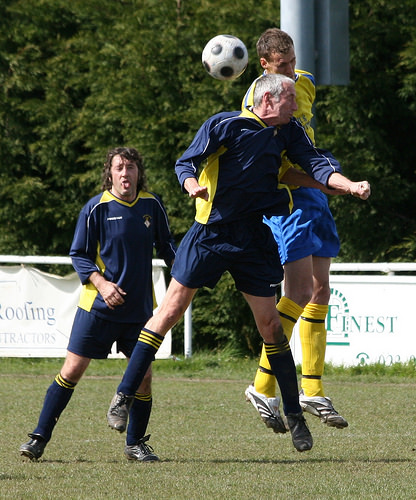<image>
Is the sock on the man? No. The sock is not positioned on the man. They may be near each other, but the sock is not supported by or resting on top of the man. Is the man behind the ball? Yes. From this viewpoint, the man is positioned behind the ball, with the ball partially or fully occluding the man. Where is the person in relation to the ground? Is it above the ground? Yes. The person is positioned above the ground in the vertical space, higher up in the scene. 